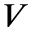Convert formula to latex. <formula><loc_0><loc_0><loc_500><loc_500>V</formula> 